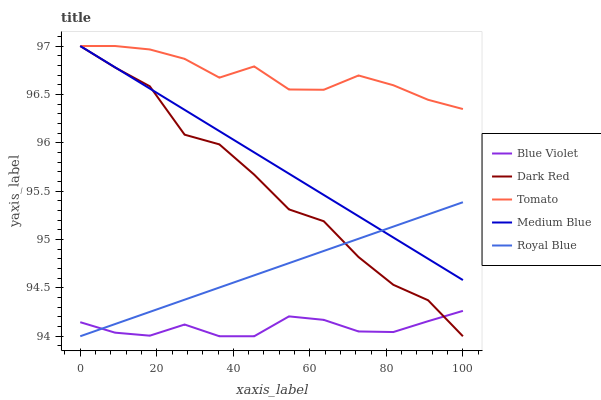Does Blue Violet have the minimum area under the curve?
Answer yes or no. Yes. Does Tomato have the maximum area under the curve?
Answer yes or no. Yes. Does Dark Red have the minimum area under the curve?
Answer yes or no. No. Does Dark Red have the maximum area under the curve?
Answer yes or no. No. Is Medium Blue the smoothest?
Answer yes or no. Yes. Is Dark Red the roughest?
Answer yes or no. Yes. Is Dark Red the smoothest?
Answer yes or no. No. Is Medium Blue the roughest?
Answer yes or no. No. Does Dark Red have the lowest value?
Answer yes or no. Yes. Does Medium Blue have the lowest value?
Answer yes or no. No. Does Medium Blue have the highest value?
Answer yes or no. Yes. Does Blue Violet have the highest value?
Answer yes or no. No. Is Royal Blue less than Tomato?
Answer yes or no. Yes. Is Tomato greater than Royal Blue?
Answer yes or no. Yes. Does Dark Red intersect Tomato?
Answer yes or no. Yes. Is Dark Red less than Tomato?
Answer yes or no. No. Is Dark Red greater than Tomato?
Answer yes or no. No. Does Royal Blue intersect Tomato?
Answer yes or no. No. 